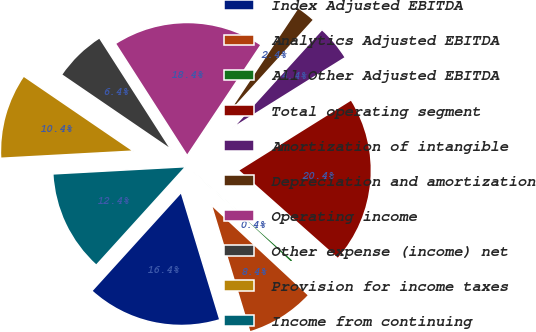<chart> <loc_0><loc_0><loc_500><loc_500><pie_chart><fcel>Index Adjusted EBITDA<fcel>Analytics Adjusted EBITDA<fcel>All Other Adjusted EBITDA<fcel>Total operating segment<fcel>Amortization of intangible<fcel>Depreciation and amortization<fcel>Operating income<fcel>Other expense (income) net<fcel>Provision for income taxes<fcel>Income from continuing<nl><fcel>16.42%<fcel>8.39%<fcel>0.37%<fcel>20.44%<fcel>4.38%<fcel>2.37%<fcel>18.43%<fcel>6.39%<fcel>10.4%<fcel>12.41%<nl></chart> 